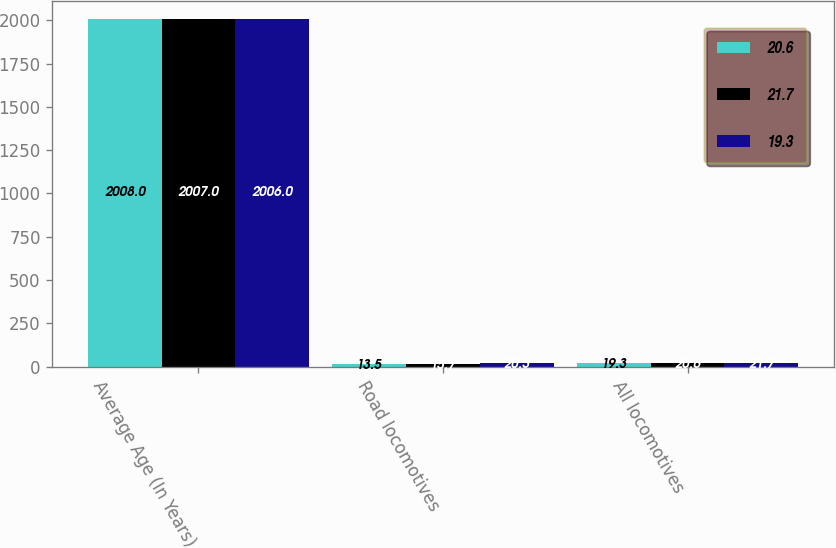Convert chart. <chart><loc_0><loc_0><loc_500><loc_500><stacked_bar_chart><ecel><fcel>Average Age (In Years)<fcel>Road locomotives<fcel>All locomotives<nl><fcel>20.6<fcel>2008<fcel>13.5<fcel>19.3<nl><fcel>21.7<fcel>2007<fcel>15.7<fcel>20.6<nl><fcel>19.3<fcel>2006<fcel>20.3<fcel>21.7<nl></chart> 